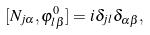Convert formula to latex. <formula><loc_0><loc_0><loc_500><loc_500>[ N _ { j \alpha } , \varphi _ { l \beta } ^ { 0 } ] = i \delta _ { j l } \delta _ { \alpha \beta } ,</formula> 